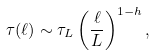Convert formula to latex. <formula><loc_0><loc_0><loc_500><loc_500>\tau ( \ell ) \sim \tau _ { L } \left ( \frac { \ell } { L } \right ) ^ { 1 - h } ,</formula> 